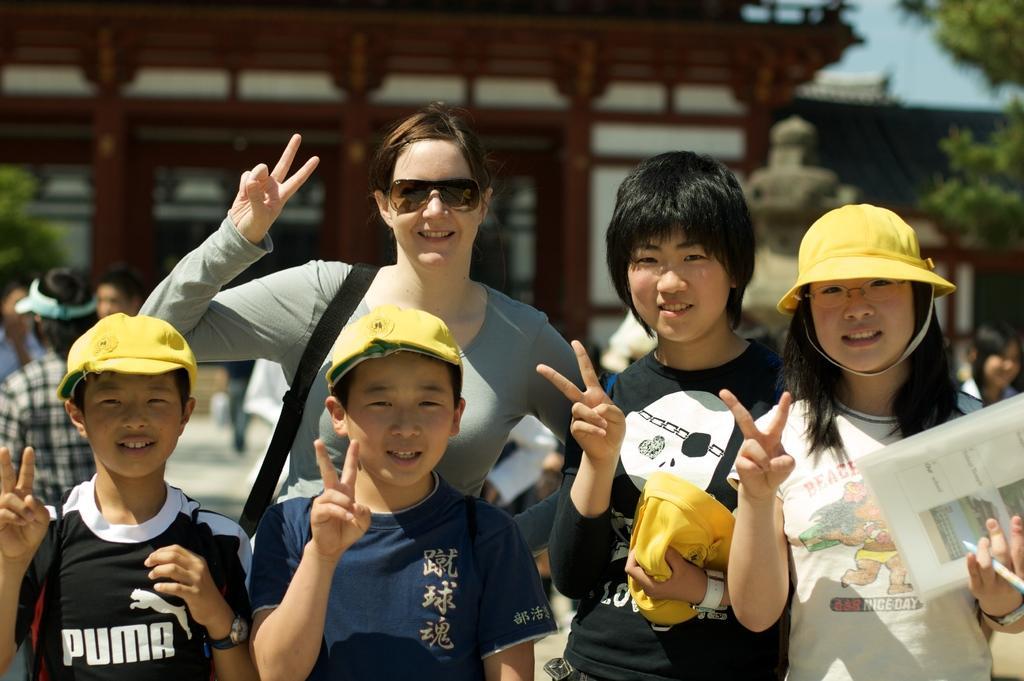Can you describe this image briefly? In this image there are four kids and a woman standing. They are wearing caps. The girl to the right is holding a paper and a pen in her hand. Behind them there are a few people standing. In the background there are buildings and trees. There is a sculpture in front of the building. 